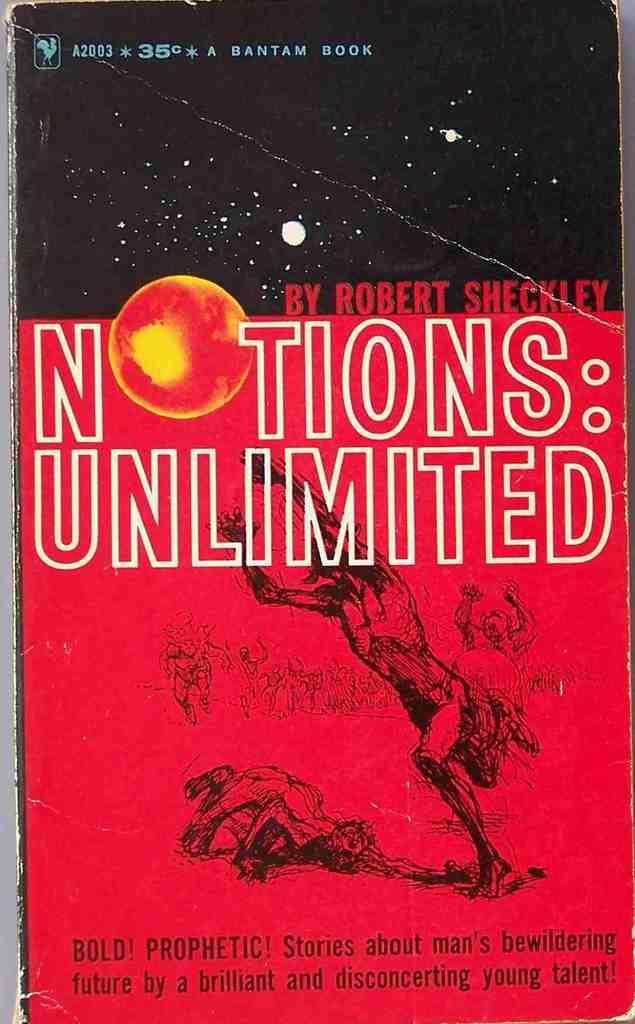Provide a one-sentence caption for the provided image. A book by Robert Sheckley has a red and black cover. 